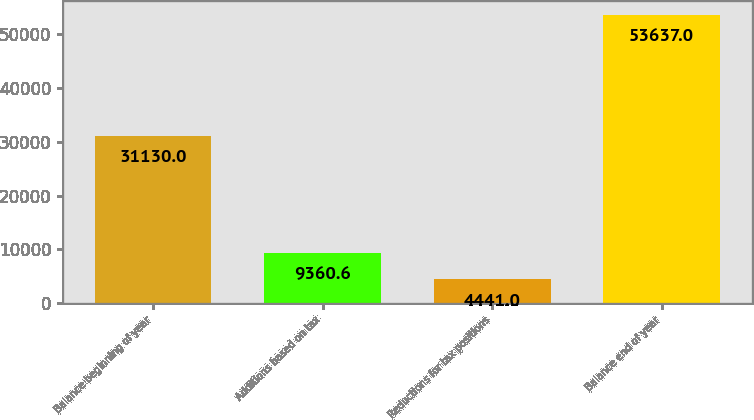Convert chart to OTSL. <chart><loc_0><loc_0><loc_500><loc_500><bar_chart><fcel>Balance beginning of year<fcel>Additions based on tax<fcel>Reductions for tax positions<fcel>Balance end of year<nl><fcel>31130<fcel>9360.6<fcel>4441<fcel>53637<nl></chart> 